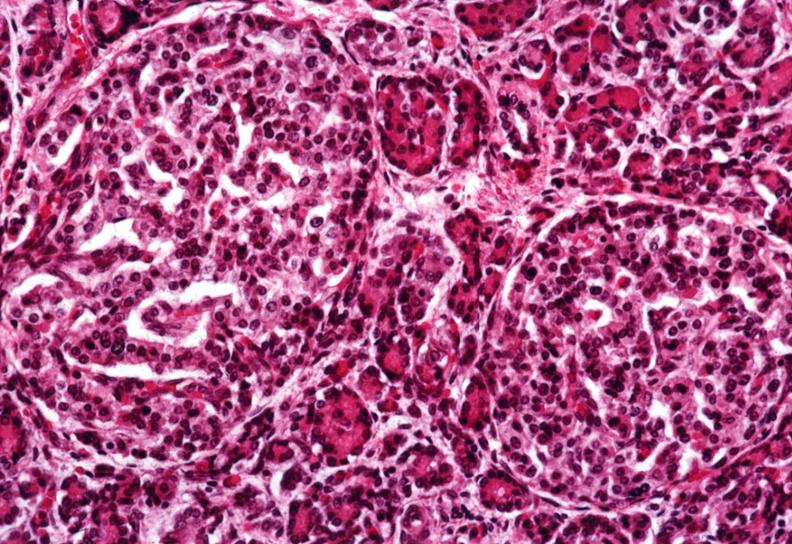where is this?
Answer the question using a single word or phrase. Pancreas 